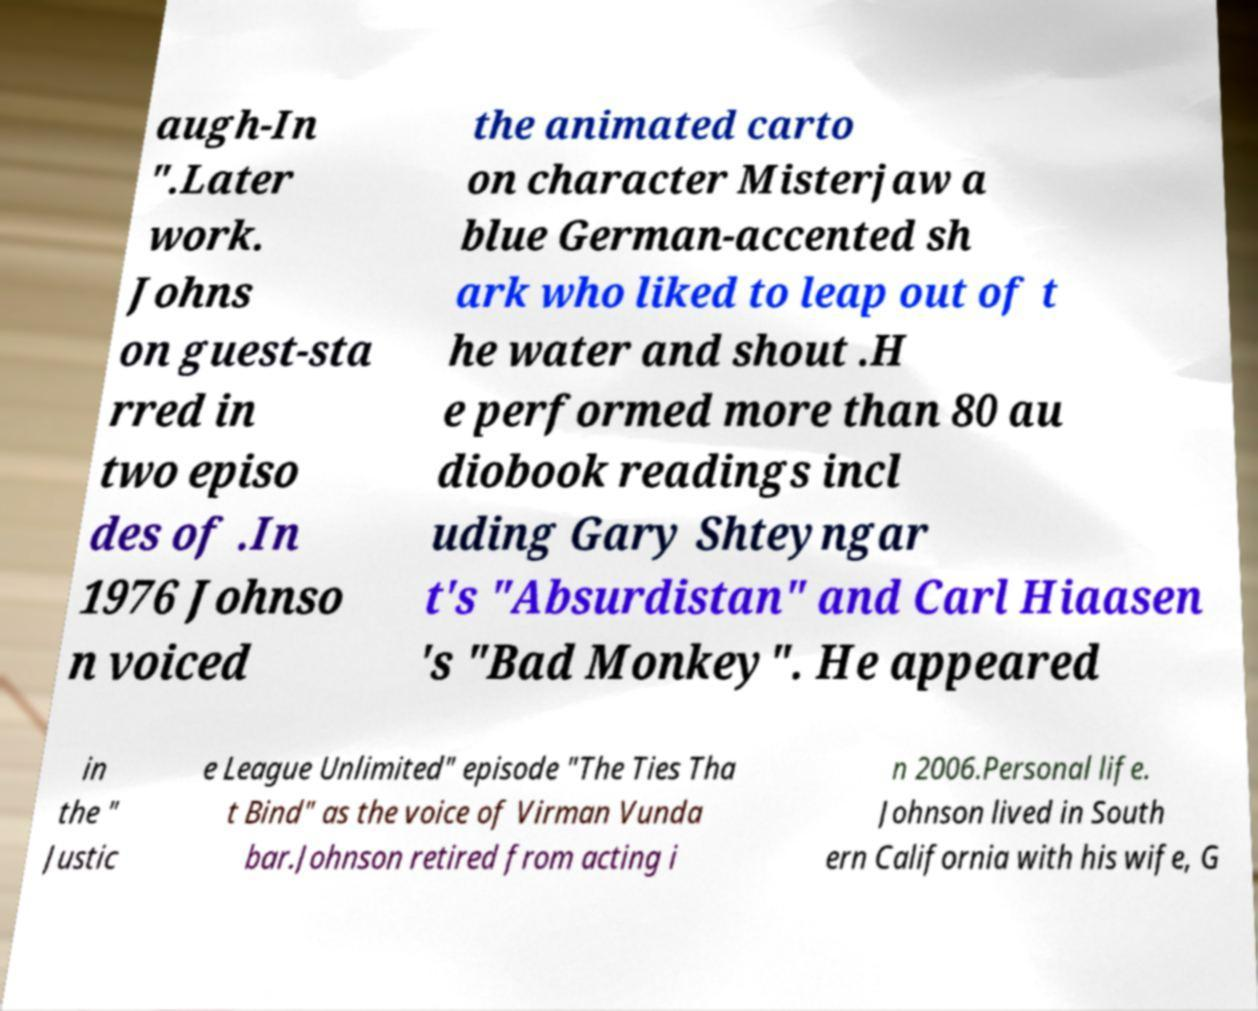Please read and relay the text visible in this image. What does it say? augh-In ".Later work. Johns on guest-sta rred in two episo des of .In 1976 Johnso n voiced the animated carto on character Misterjaw a blue German-accented sh ark who liked to leap out of t he water and shout .H e performed more than 80 au diobook readings incl uding Gary Shteyngar t's "Absurdistan" and Carl Hiaasen 's "Bad Monkey". He appeared in the " Justic e League Unlimited" episode "The Ties Tha t Bind" as the voice of Virman Vunda bar.Johnson retired from acting i n 2006.Personal life. Johnson lived in South ern California with his wife, G 